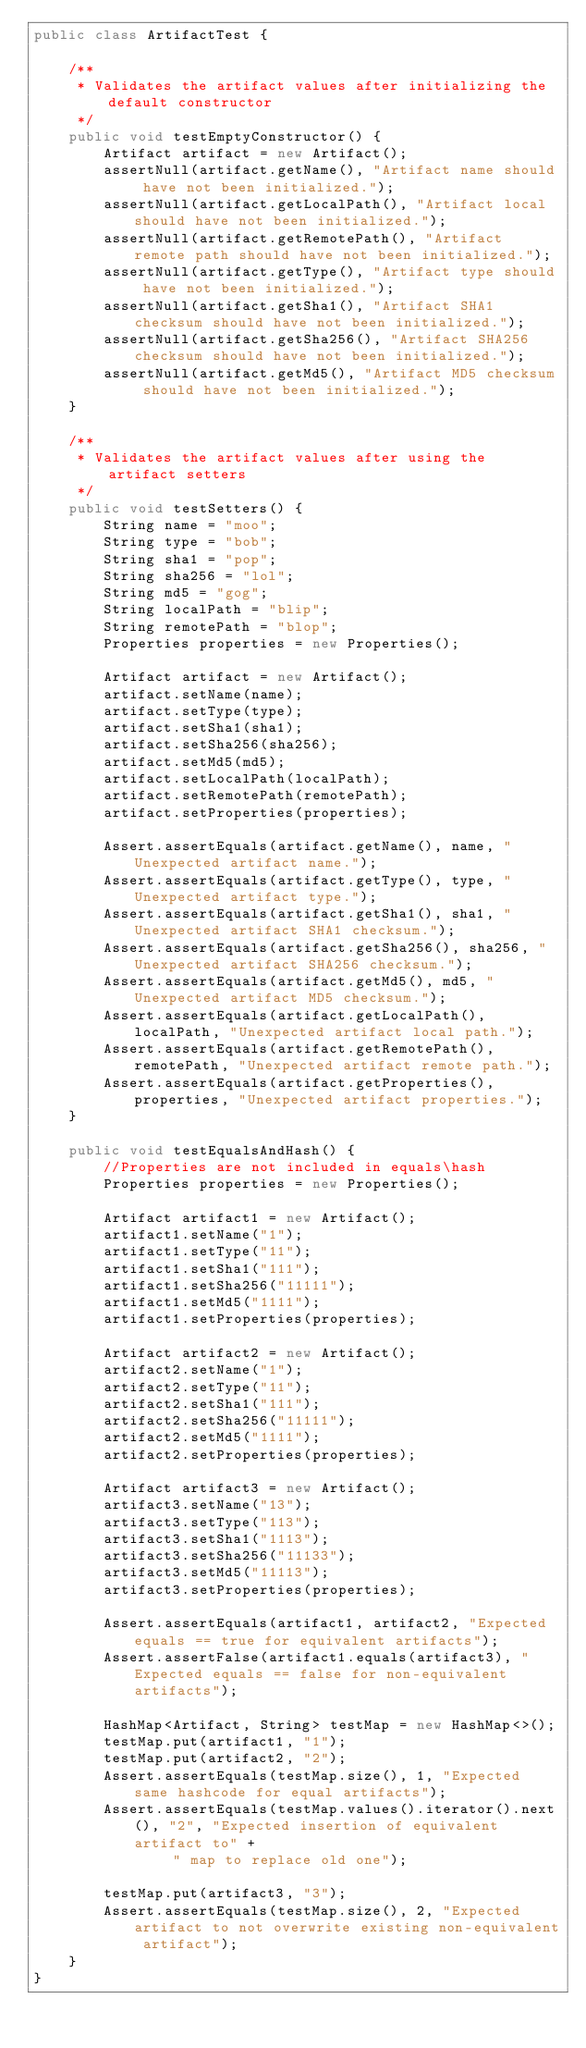Convert code to text. <code><loc_0><loc_0><loc_500><loc_500><_Java_>public class ArtifactTest {

    /**
     * Validates the artifact values after initializing the default constructor
     */
    public void testEmptyConstructor() {
        Artifact artifact = new Artifact();
        assertNull(artifact.getName(), "Artifact name should have not been initialized.");
        assertNull(artifact.getLocalPath(), "Artifact local should have not been initialized.");
        assertNull(artifact.getRemotePath(), "Artifact remote path should have not been initialized.");
        assertNull(artifact.getType(), "Artifact type should have not been initialized.");
        assertNull(artifact.getSha1(), "Artifact SHA1 checksum should have not been initialized.");
        assertNull(artifact.getSha256(), "Artifact SHA256 checksum should have not been initialized.");
        assertNull(artifact.getMd5(), "Artifact MD5 checksum should have not been initialized.");
    }

    /**
     * Validates the artifact values after using the artifact setters
     */
    public void testSetters() {
        String name = "moo";
        String type = "bob";
        String sha1 = "pop";
        String sha256 = "lol";
        String md5 = "gog";
        String localPath = "blip";
        String remotePath = "blop";
        Properties properties = new Properties();

        Artifact artifact = new Artifact();
        artifact.setName(name);
        artifact.setType(type);
        artifact.setSha1(sha1);
        artifact.setSha256(sha256);
        artifact.setMd5(md5);
        artifact.setLocalPath(localPath);
        artifact.setRemotePath(remotePath);
        artifact.setProperties(properties);

        Assert.assertEquals(artifact.getName(), name, "Unexpected artifact name.");
        Assert.assertEquals(artifact.getType(), type, "Unexpected artifact type.");
        Assert.assertEquals(artifact.getSha1(), sha1, "Unexpected artifact SHA1 checksum.");
        Assert.assertEquals(artifact.getSha256(), sha256, "Unexpected artifact SHA256 checksum.");
        Assert.assertEquals(artifact.getMd5(), md5, "Unexpected artifact MD5 checksum.");
        Assert.assertEquals(artifact.getLocalPath(), localPath, "Unexpected artifact local path.");
        Assert.assertEquals(artifact.getRemotePath(), remotePath, "Unexpected artifact remote path.");
        Assert.assertEquals(artifact.getProperties(), properties, "Unexpected artifact properties.");
    }

    public void testEqualsAndHash() {
        //Properties are not included in equals\hash
        Properties properties = new Properties();

        Artifact artifact1 = new Artifact();
        artifact1.setName("1");
        artifact1.setType("11");
        artifact1.setSha1("111");
        artifact1.setSha256("11111");
        artifact1.setMd5("1111");
        artifact1.setProperties(properties);

        Artifact artifact2 = new Artifact();
        artifact2.setName("1");
        artifact2.setType("11");
        artifact2.setSha1("111");
        artifact2.setSha256("11111");
        artifact2.setMd5("1111");
        artifact2.setProperties(properties);

        Artifact artifact3 = new Artifact();
        artifact3.setName("13");
        artifact3.setType("113");
        artifact3.setSha1("1113");
        artifact3.setSha256("11133");
        artifact3.setMd5("11113");
        artifact3.setProperties(properties);

        Assert.assertEquals(artifact1, artifact2, "Expected equals == true for equivalent artifacts");
        Assert.assertFalse(artifact1.equals(artifact3), "Expected equals == false for non-equivalent artifacts");

        HashMap<Artifact, String> testMap = new HashMap<>();
        testMap.put(artifact1, "1");
        testMap.put(artifact2, "2");
        Assert.assertEquals(testMap.size(), 1, "Expected same hashcode for equal artifacts");
        Assert.assertEquals(testMap.values().iterator().next(), "2", "Expected insertion of equivalent artifact to" +
                " map to replace old one");

        testMap.put(artifact3, "3");
        Assert.assertEquals(testMap.size(), 2, "Expected artifact to not overwrite existing non-equivalent artifact");
    }
}</code> 